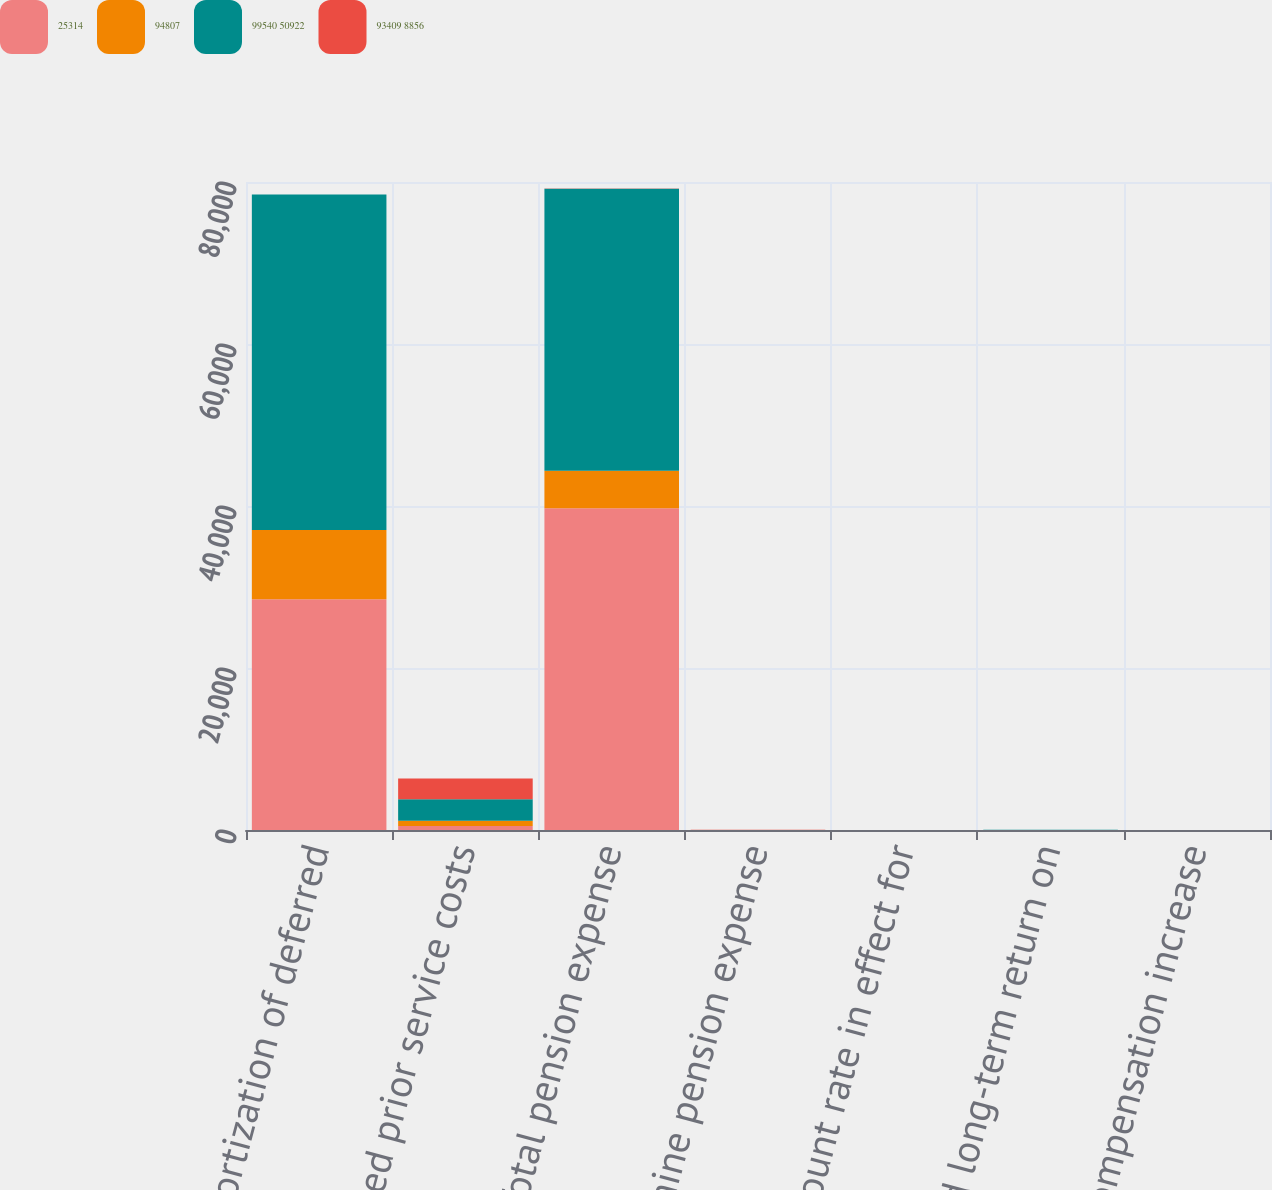Convert chart. <chart><loc_0><loc_0><loc_500><loc_500><stacked_bar_chart><ecel><fcel>Amortization of deferred<fcel>Deferred prior service costs<fcel>Total pension expense<fcel>determine pension expense<fcel>Discount rate in effect for<fcel>Expected long-term return on<fcel>Rate of compensation increase<nl><fcel>25314<fcel>28474<fcel>494<fcel>39731<fcel>3.85<fcel>3.51<fcel>5.58<fcel>3.73<nl><fcel>94807<fcel>8548<fcel>647<fcel>4618<fcel>3.58<fcel>3.13<fcel>5.72<fcel>3.73<nl><fcel>99540 50922<fcel>41440<fcel>2646<fcel>34829<fcel>4.08<fcel>3.26<fcel>5.72<fcel>3.78<nl><fcel>93409 8856<fcel>5.65<fcel>2584<fcel>5.65<fcel>4.54<fcel>3.56<fcel>5.81<fcel>3.9<nl></chart> 